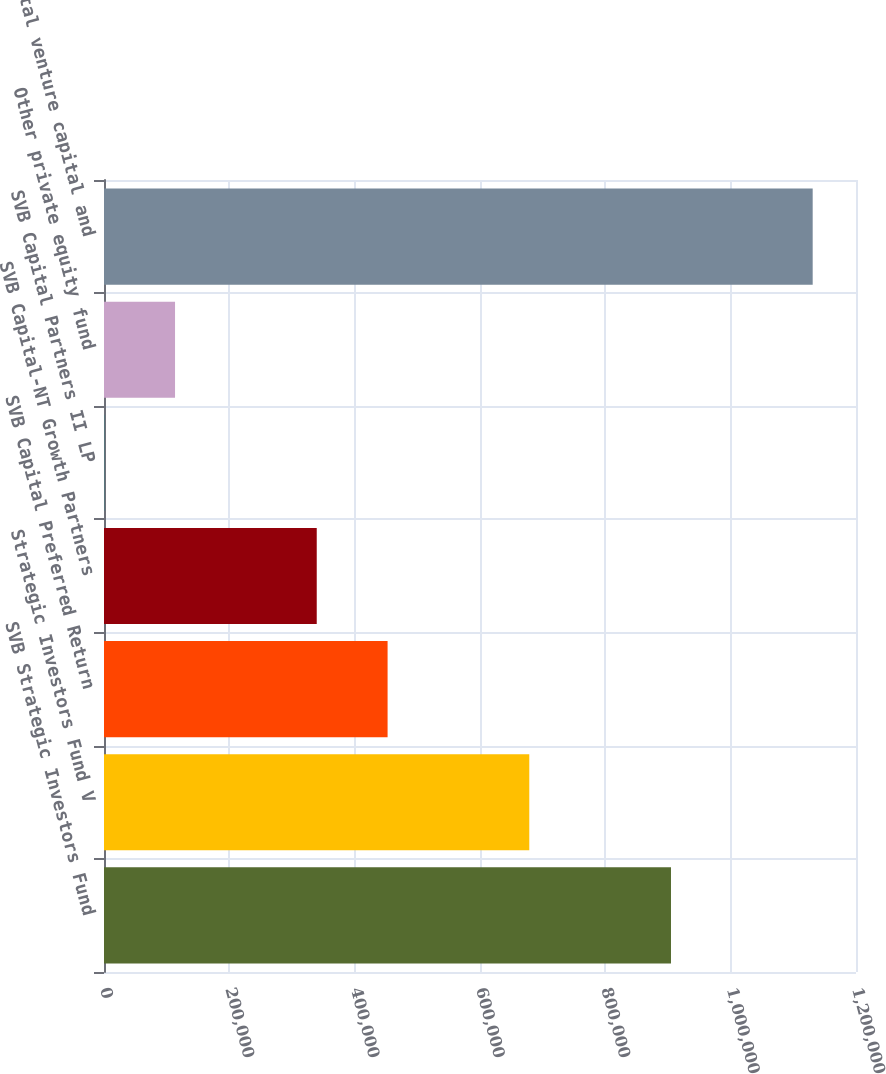Convert chart to OTSL. <chart><loc_0><loc_0><loc_500><loc_500><bar_chart><fcel>SVB Strategic Investors Fund<fcel>Strategic Investors Fund V<fcel>SVB Capital Preferred Return<fcel>SVB Capital-NT Growth Partners<fcel>SVB Capital Partners II LP<fcel>Other private equity fund<fcel>Total venture capital and<nl><fcel>904766<fcel>678650<fcel>452534<fcel>339476<fcel>302<fcel>113360<fcel>1.13088e+06<nl></chart> 